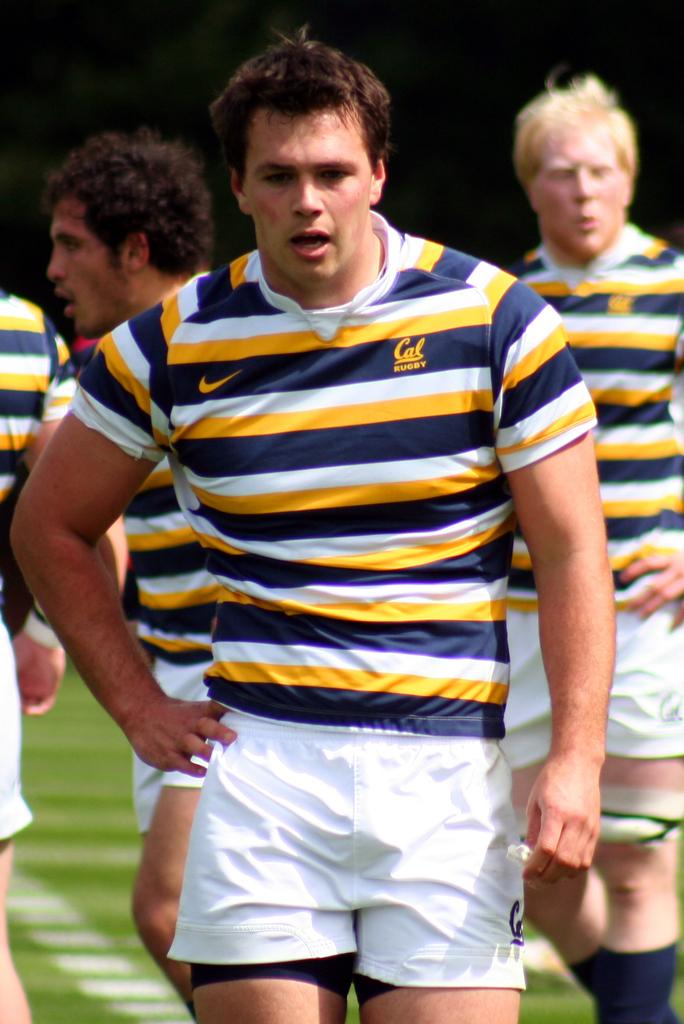What are the people in the image doing? The persons in the image are walking. What type of surface are the people walking on? There is grass on the ground in the image. What type of whip can be seen in the hands of the persons walking in the image? There is no whip present in the image; the persons are simply walking. 